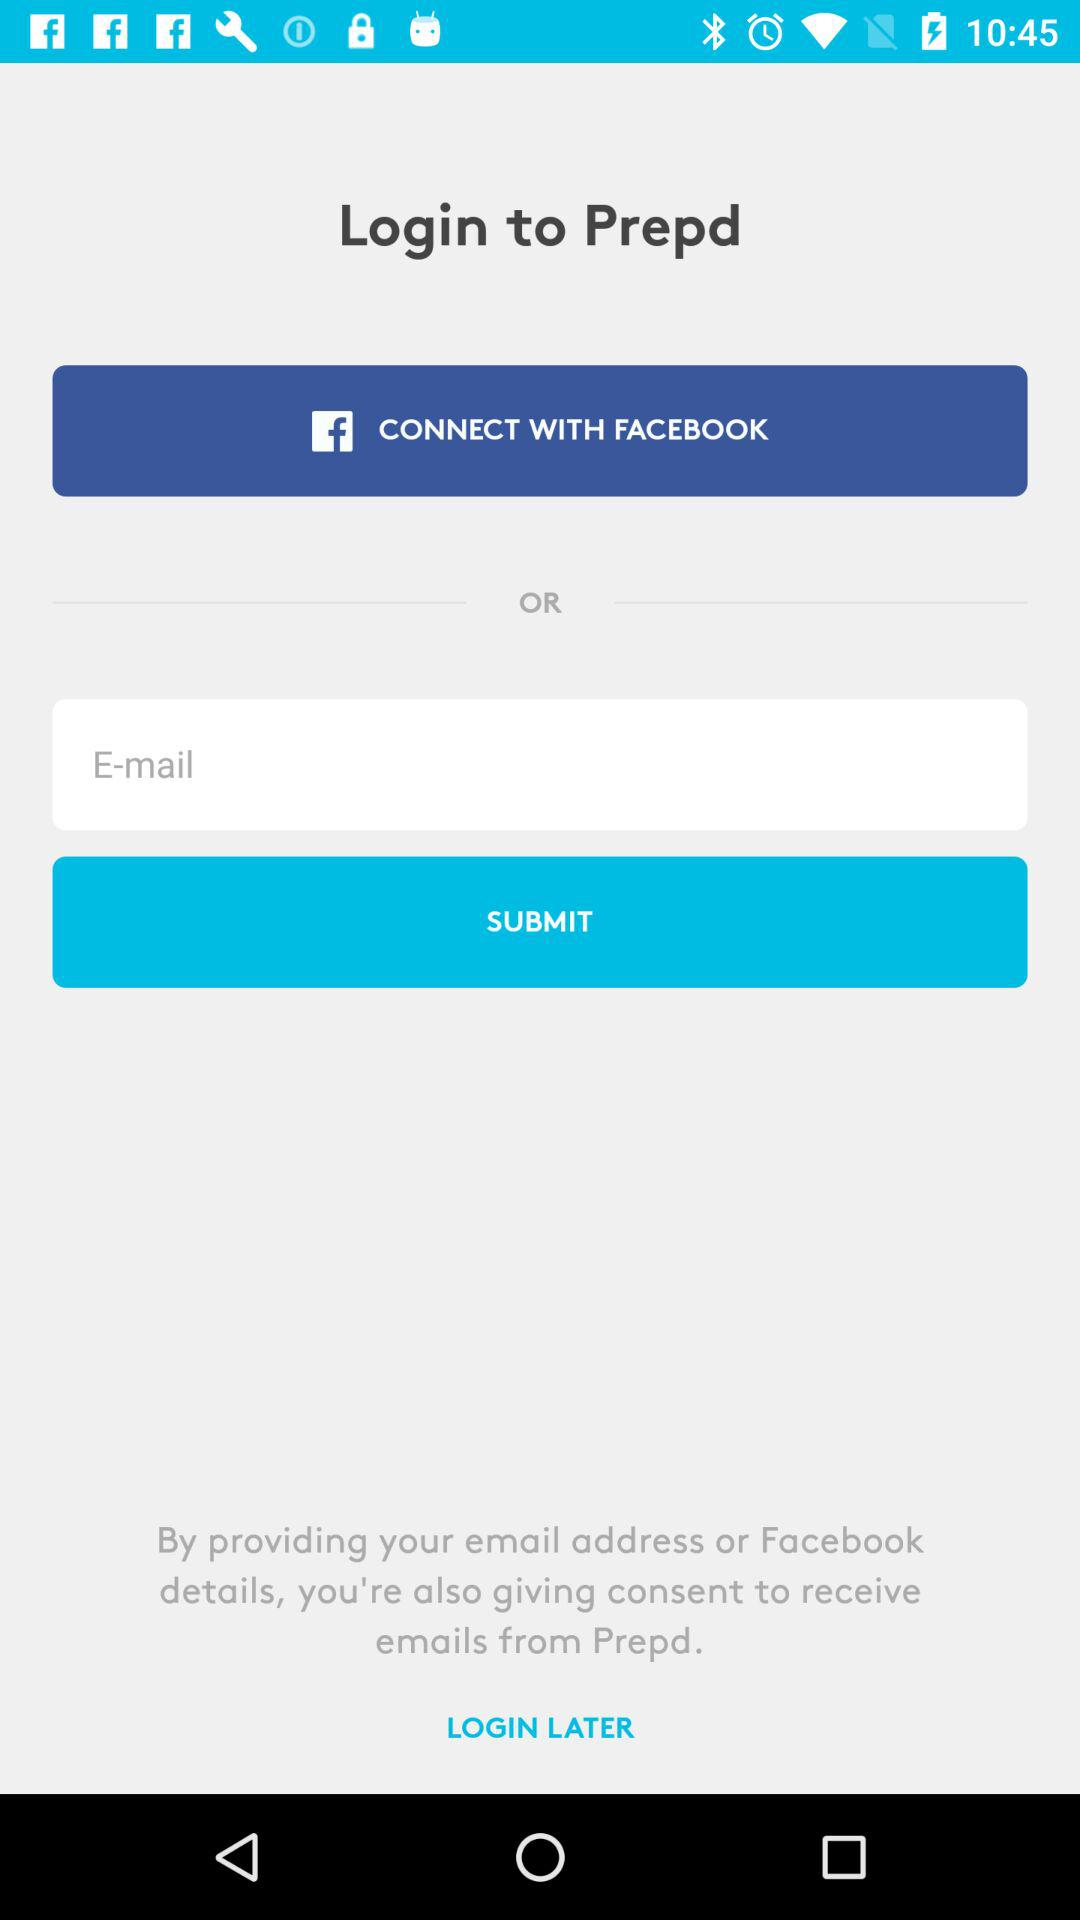How many inputs are there on the screen?
Answer the question using a single word or phrase. 1 